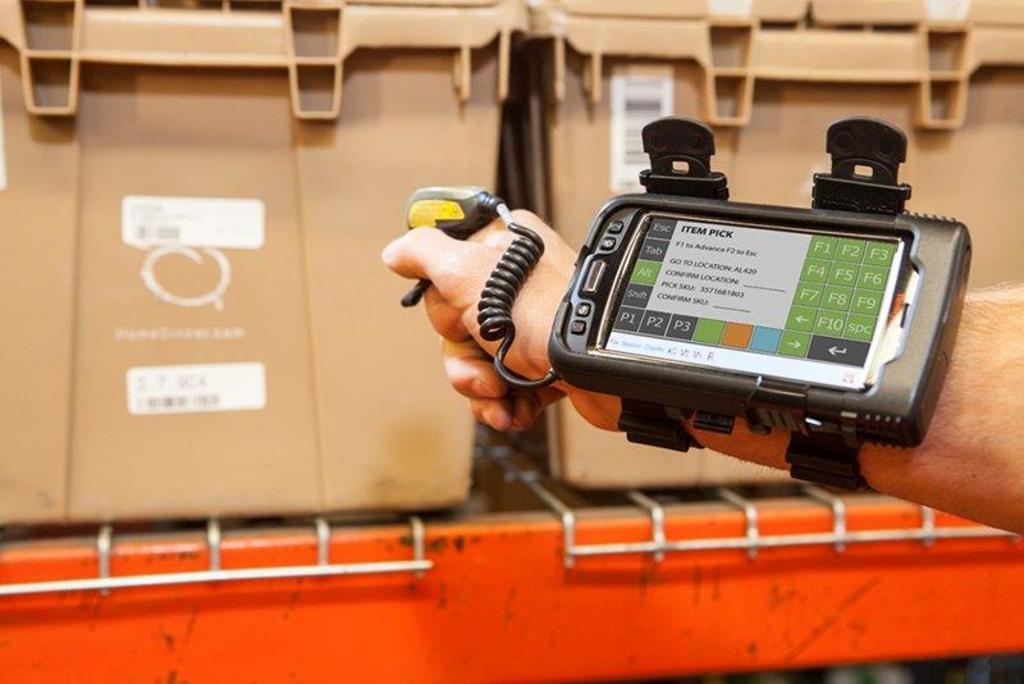What is the title on the white box on the screen?
Provide a short and direct response. Item pick. What is the first box you can select on the wrist device in the bottom left hand corner?
Keep it short and to the point. P1. 